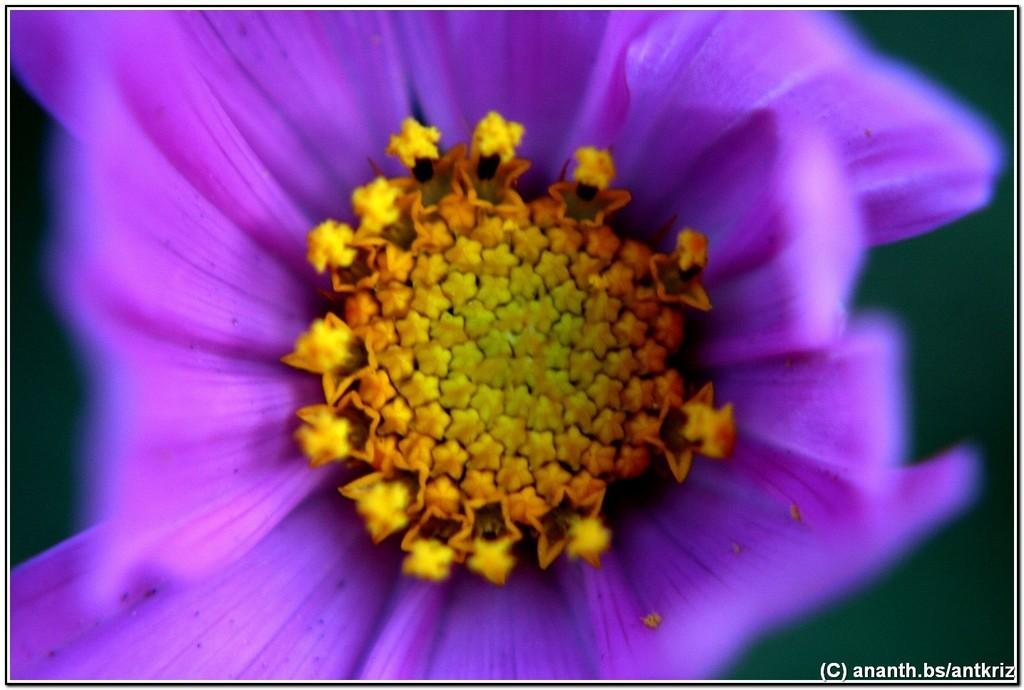What is the main subject in the center of the image? There is a flower in the center of the image. What else can be seen at the bottom of the image? There is text at the bottom of the image. Can you see any snow in the image? There is no snow present in the image. Is there an airplane visible in the image? No, there is no airplane in the image. 